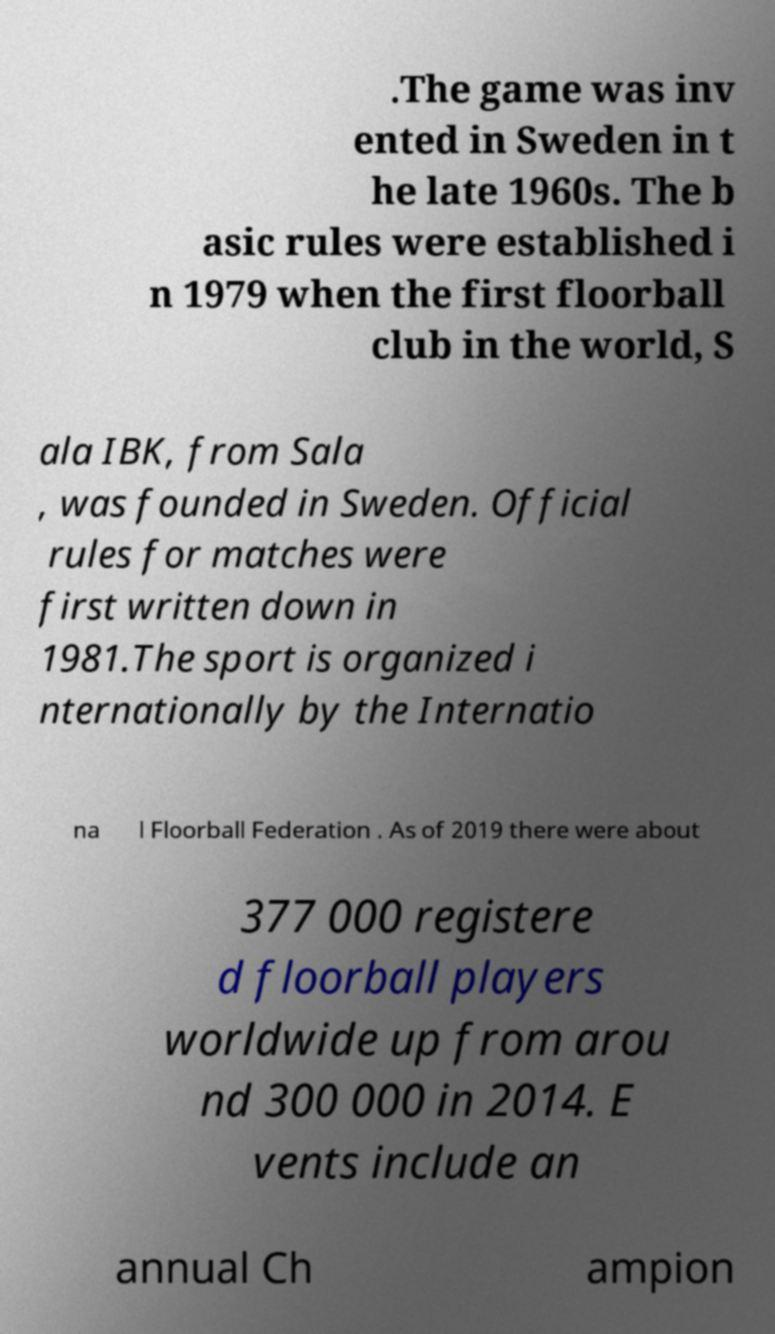There's text embedded in this image that I need extracted. Can you transcribe it verbatim? .The game was inv ented in Sweden in t he late 1960s. The b asic rules were established i n 1979 when the first floorball club in the world, S ala IBK, from Sala , was founded in Sweden. Official rules for matches were first written down in 1981.The sport is organized i nternationally by the Internatio na l Floorball Federation . As of 2019 there were about 377 000 registere d floorball players worldwide up from arou nd 300 000 in 2014. E vents include an annual Ch ampion 